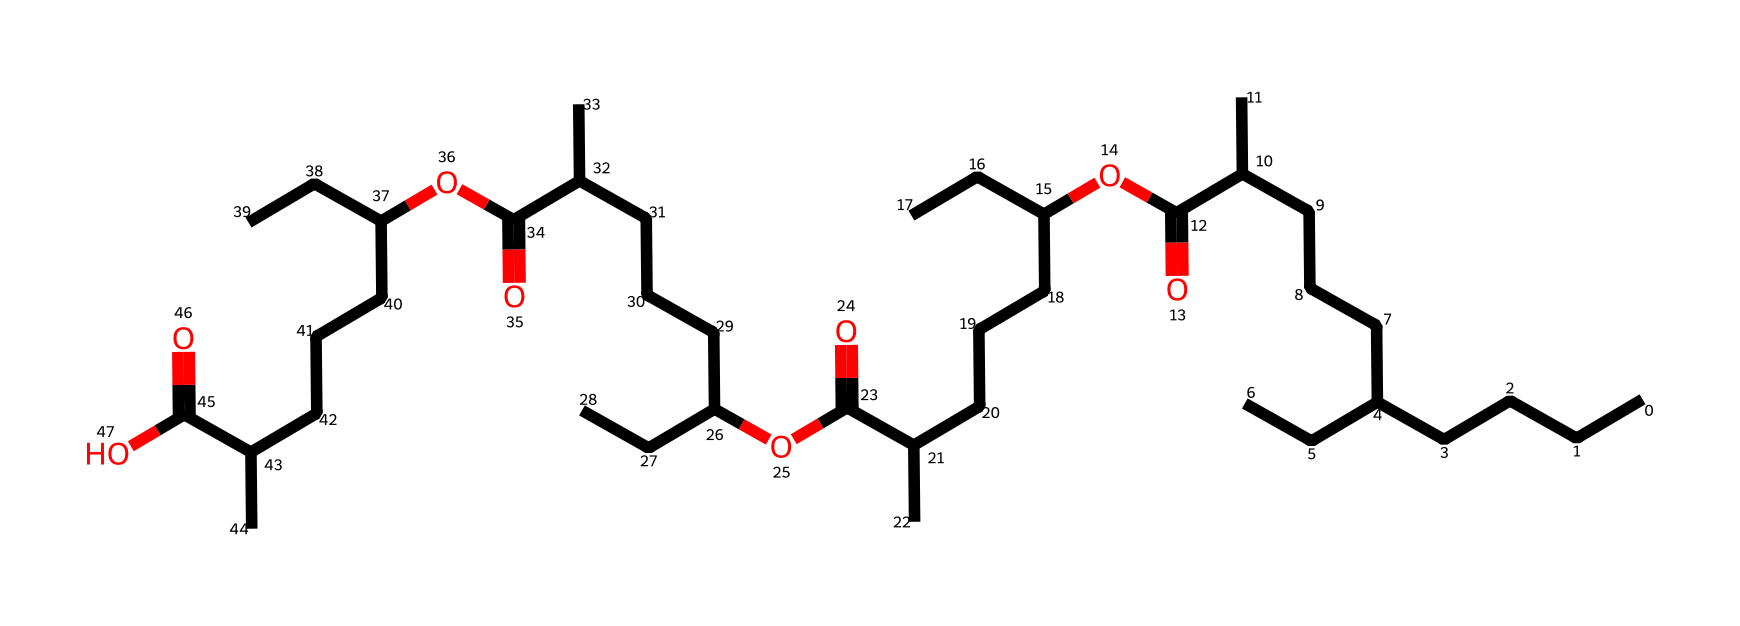What is the total number of carbon atoms in this chemical? By analyzing the SMILES representation, each "C" represents a carbon atom. Counting all occurrences in the sequence, we find there are 40 carbon atoms.
Answer: 40 How many ester functional groups are present in this chemical? The chemical contains multiple instances of the structure "C(=O)O" which indicates ester groups. In this representation, we can observe four ester groups contributing to the structure.
Answer: 4 Which characteristic of this hydrocarbon suggests it is suitable for steam engine lubricants? The presence of multiple alkyl chains (indicated by long carbon chains) suggests a viscous soft consistency, which is ideal for lubrication.
Answer: viscosity What is the primary functional group identified in this chemical structure? The primary functional groups identified from the structures are the ester groups, which are prominently featured.
Answer: ester Which type of hydrocarbon does this compound represent? Based on the structure primarily composed of carbon and hydrogen with no heteroatoms present, this compound is classified as a saturated hydrocarbon.
Answer: saturated hydrocarbons 